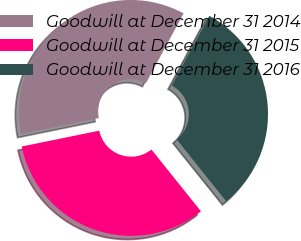Convert chart. <chart><loc_0><loc_0><loc_500><loc_500><pie_chart><fcel>Goodwill at December 31 2014<fcel>Goodwill at December 31 2015<fcel>Goodwill at December 31 2016<nl><fcel>36.07%<fcel>32.55%<fcel>31.38%<nl></chart> 